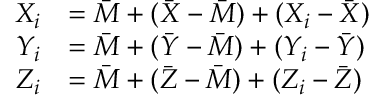Convert formula to latex. <formula><loc_0><loc_0><loc_500><loc_500>{ \begin{array} { r l } { X _ { i } } & { = { \bar { M } } + ( { \bar { X } } - { \bar { M } } ) + ( X _ { i } - { \bar { X } } ) } \\ { Y _ { i } } & { = { \bar { M } } + ( { \bar { Y } } - { \bar { M } } ) + ( Y _ { i } - { \bar { Y } } ) } \\ { Z _ { i } } & { = { \bar { M } } + ( { \bar { Z } } - { \bar { M } } ) + ( Z _ { i } - { \bar { Z } } ) } \end{array} }</formula> 